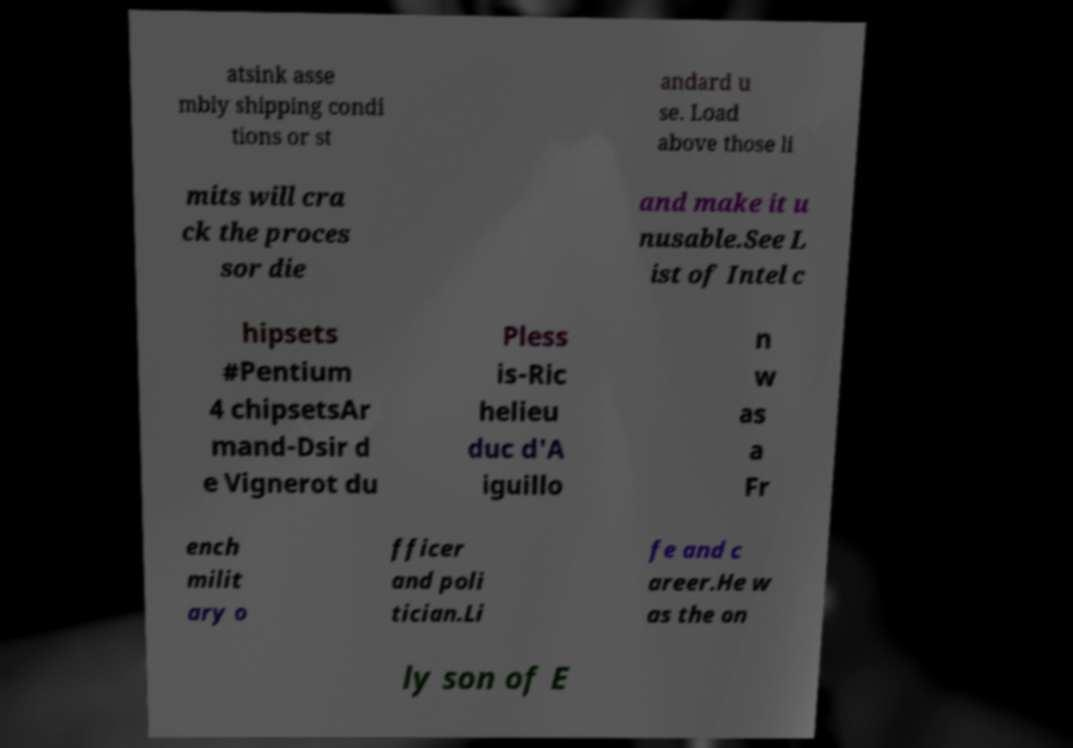Could you assist in decoding the text presented in this image and type it out clearly? atsink asse mbly shipping condi tions or st andard u se. Load above those li mits will cra ck the proces sor die and make it u nusable.See L ist of Intel c hipsets #Pentium 4 chipsetsAr mand-Dsir d e Vignerot du Pless is-Ric helieu duc d'A iguillo n w as a Fr ench milit ary o fficer and poli tician.Li fe and c areer.He w as the on ly son of E 